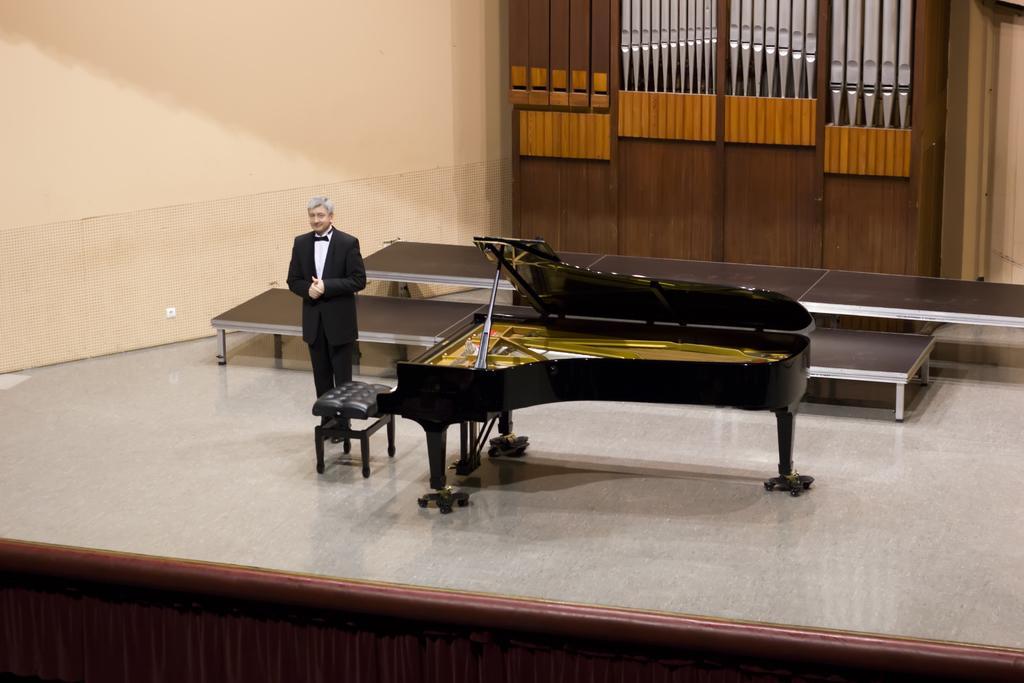Please provide a concise description of this image. In this picture we can see a man standing on the floor. This is the chair. And there is a musical instrument and on the background there is a wall. And this is the door. 